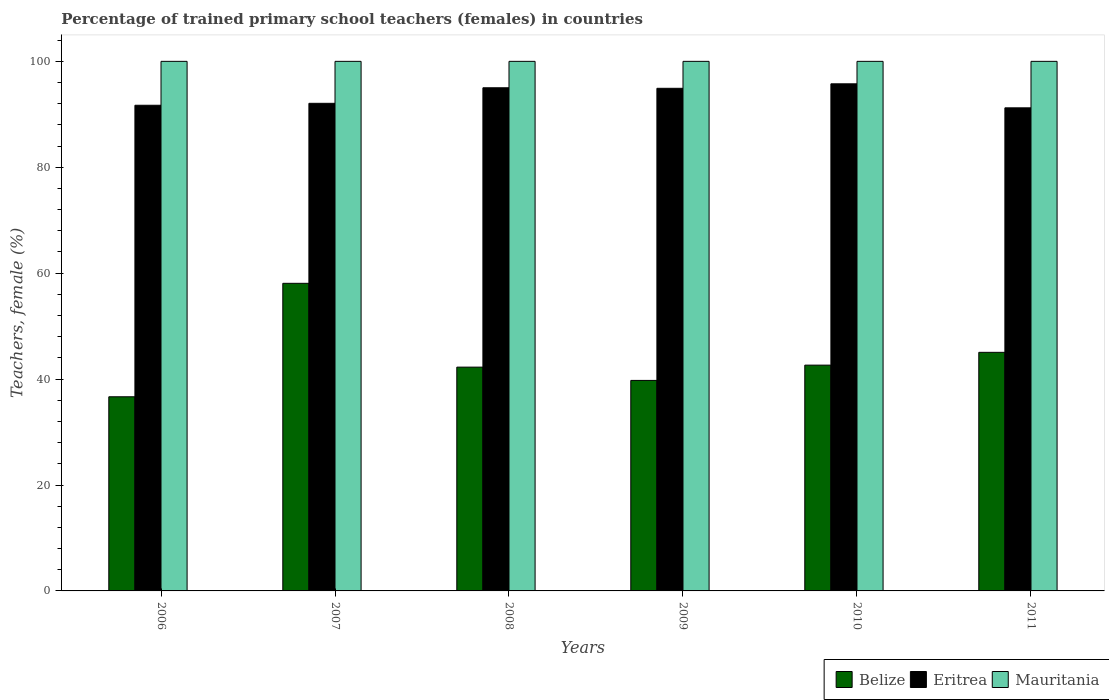How many different coloured bars are there?
Give a very brief answer. 3. Are the number of bars per tick equal to the number of legend labels?
Give a very brief answer. Yes. What is the label of the 1st group of bars from the left?
Your answer should be compact. 2006. What is the percentage of trained primary school teachers (females) in Mauritania in 2011?
Offer a terse response. 100. Across all years, what is the maximum percentage of trained primary school teachers (females) in Eritrea?
Ensure brevity in your answer.  95.76. In which year was the percentage of trained primary school teachers (females) in Eritrea minimum?
Your answer should be very brief. 2011. What is the total percentage of trained primary school teachers (females) in Eritrea in the graph?
Your response must be concise. 560.69. What is the difference between the percentage of trained primary school teachers (females) in Belize in 2007 and that in 2010?
Make the answer very short. 15.45. What is the difference between the percentage of trained primary school teachers (females) in Eritrea in 2010 and the percentage of trained primary school teachers (females) in Mauritania in 2006?
Make the answer very short. -4.24. What is the average percentage of trained primary school teachers (females) in Belize per year?
Provide a succinct answer. 44.07. In the year 2011, what is the difference between the percentage of trained primary school teachers (females) in Eritrea and percentage of trained primary school teachers (females) in Belize?
Offer a very short reply. 46.17. Is the difference between the percentage of trained primary school teachers (females) in Eritrea in 2007 and 2010 greater than the difference between the percentage of trained primary school teachers (females) in Belize in 2007 and 2010?
Your answer should be very brief. No. What is the difference between the highest and the second highest percentage of trained primary school teachers (females) in Eritrea?
Offer a terse response. 0.75. What is the difference between the highest and the lowest percentage of trained primary school teachers (females) in Belize?
Your response must be concise. 21.42. In how many years, is the percentage of trained primary school teachers (females) in Mauritania greater than the average percentage of trained primary school teachers (females) in Mauritania taken over all years?
Offer a terse response. 0. What does the 2nd bar from the left in 2008 represents?
Make the answer very short. Eritrea. What does the 3rd bar from the right in 2006 represents?
Offer a terse response. Belize. Is it the case that in every year, the sum of the percentage of trained primary school teachers (females) in Mauritania and percentage of trained primary school teachers (females) in Belize is greater than the percentage of trained primary school teachers (females) in Eritrea?
Your response must be concise. Yes. How many years are there in the graph?
Offer a terse response. 6. Does the graph contain any zero values?
Your answer should be compact. No. How are the legend labels stacked?
Offer a terse response. Horizontal. What is the title of the graph?
Ensure brevity in your answer.  Percentage of trained primary school teachers (females) in countries. Does "Qatar" appear as one of the legend labels in the graph?
Make the answer very short. No. What is the label or title of the X-axis?
Keep it short and to the point. Years. What is the label or title of the Y-axis?
Offer a terse response. Teachers, female (%). What is the Teachers, female (%) of Belize in 2006?
Give a very brief answer. 36.66. What is the Teachers, female (%) in Eritrea in 2006?
Provide a short and direct response. 91.71. What is the Teachers, female (%) of Belize in 2007?
Give a very brief answer. 58.08. What is the Teachers, female (%) of Eritrea in 2007?
Your response must be concise. 92.08. What is the Teachers, female (%) of Mauritania in 2007?
Ensure brevity in your answer.  100. What is the Teachers, female (%) in Belize in 2008?
Your answer should be very brief. 42.26. What is the Teachers, female (%) in Eritrea in 2008?
Ensure brevity in your answer.  95.01. What is the Teachers, female (%) in Belize in 2009?
Offer a terse response. 39.75. What is the Teachers, female (%) of Eritrea in 2009?
Provide a short and direct response. 94.91. What is the Teachers, female (%) in Belize in 2010?
Provide a succinct answer. 42.64. What is the Teachers, female (%) in Eritrea in 2010?
Provide a short and direct response. 95.76. What is the Teachers, female (%) of Belize in 2011?
Ensure brevity in your answer.  45.05. What is the Teachers, female (%) in Eritrea in 2011?
Provide a short and direct response. 91.22. Across all years, what is the maximum Teachers, female (%) of Belize?
Offer a very short reply. 58.08. Across all years, what is the maximum Teachers, female (%) in Eritrea?
Make the answer very short. 95.76. Across all years, what is the maximum Teachers, female (%) in Mauritania?
Offer a very short reply. 100. Across all years, what is the minimum Teachers, female (%) in Belize?
Your answer should be very brief. 36.66. Across all years, what is the minimum Teachers, female (%) of Eritrea?
Your response must be concise. 91.22. What is the total Teachers, female (%) in Belize in the graph?
Your response must be concise. 264.45. What is the total Teachers, female (%) of Eritrea in the graph?
Offer a very short reply. 560.69. What is the total Teachers, female (%) of Mauritania in the graph?
Offer a terse response. 600. What is the difference between the Teachers, female (%) in Belize in 2006 and that in 2007?
Provide a succinct answer. -21.42. What is the difference between the Teachers, female (%) of Eritrea in 2006 and that in 2007?
Offer a terse response. -0.37. What is the difference between the Teachers, female (%) in Mauritania in 2006 and that in 2007?
Your answer should be compact. 0. What is the difference between the Teachers, female (%) of Belize in 2006 and that in 2008?
Provide a succinct answer. -5.6. What is the difference between the Teachers, female (%) in Eritrea in 2006 and that in 2008?
Your response must be concise. -3.3. What is the difference between the Teachers, female (%) in Mauritania in 2006 and that in 2008?
Offer a very short reply. 0. What is the difference between the Teachers, female (%) in Belize in 2006 and that in 2009?
Keep it short and to the point. -3.09. What is the difference between the Teachers, female (%) in Eritrea in 2006 and that in 2009?
Provide a short and direct response. -3.2. What is the difference between the Teachers, female (%) in Mauritania in 2006 and that in 2009?
Give a very brief answer. 0. What is the difference between the Teachers, female (%) of Belize in 2006 and that in 2010?
Your answer should be very brief. -5.97. What is the difference between the Teachers, female (%) of Eritrea in 2006 and that in 2010?
Ensure brevity in your answer.  -4.05. What is the difference between the Teachers, female (%) of Belize in 2006 and that in 2011?
Give a very brief answer. -8.39. What is the difference between the Teachers, female (%) of Eritrea in 2006 and that in 2011?
Offer a very short reply. 0.49. What is the difference between the Teachers, female (%) in Mauritania in 2006 and that in 2011?
Your answer should be compact. 0. What is the difference between the Teachers, female (%) of Belize in 2007 and that in 2008?
Make the answer very short. 15.82. What is the difference between the Teachers, female (%) of Eritrea in 2007 and that in 2008?
Your answer should be compact. -2.94. What is the difference between the Teachers, female (%) in Belize in 2007 and that in 2009?
Provide a short and direct response. 18.33. What is the difference between the Teachers, female (%) of Eritrea in 2007 and that in 2009?
Your answer should be very brief. -2.84. What is the difference between the Teachers, female (%) in Mauritania in 2007 and that in 2009?
Ensure brevity in your answer.  0. What is the difference between the Teachers, female (%) in Belize in 2007 and that in 2010?
Give a very brief answer. 15.45. What is the difference between the Teachers, female (%) of Eritrea in 2007 and that in 2010?
Give a very brief answer. -3.68. What is the difference between the Teachers, female (%) in Belize in 2007 and that in 2011?
Keep it short and to the point. 13.03. What is the difference between the Teachers, female (%) in Eritrea in 2007 and that in 2011?
Your answer should be compact. 0.85. What is the difference between the Teachers, female (%) in Mauritania in 2007 and that in 2011?
Give a very brief answer. 0. What is the difference between the Teachers, female (%) in Belize in 2008 and that in 2009?
Ensure brevity in your answer.  2.51. What is the difference between the Teachers, female (%) in Eritrea in 2008 and that in 2009?
Give a very brief answer. 0.1. What is the difference between the Teachers, female (%) in Belize in 2008 and that in 2010?
Keep it short and to the point. -0.38. What is the difference between the Teachers, female (%) in Eritrea in 2008 and that in 2010?
Ensure brevity in your answer.  -0.75. What is the difference between the Teachers, female (%) in Belize in 2008 and that in 2011?
Give a very brief answer. -2.79. What is the difference between the Teachers, female (%) in Eritrea in 2008 and that in 2011?
Your answer should be very brief. 3.79. What is the difference between the Teachers, female (%) in Belize in 2009 and that in 2010?
Offer a very short reply. -2.88. What is the difference between the Teachers, female (%) of Eritrea in 2009 and that in 2010?
Give a very brief answer. -0.85. What is the difference between the Teachers, female (%) of Mauritania in 2009 and that in 2010?
Provide a short and direct response. 0. What is the difference between the Teachers, female (%) of Belize in 2009 and that in 2011?
Offer a terse response. -5.3. What is the difference between the Teachers, female (%) of Eritrea in 2009 and that in 2011?
Ensure brevity in your answer.  3.69. What is the difference between the Teachers, female (%) in Mauritania in 2009 and that in 2011?
Offer a very short reply. 0. What is the difference between the Teachers, female (%) in Belize in 2010 and that in 2011?
Your answer should be very brief. -2.42. What is the difference between the Teachers, female (%) of Eritrea in 2010 and that in 2011?
Provide a short and direct response. 4.54. What is the difference between the Teachers, female (%) in Mauritania in 2010 and that in 2011?
Provide a succinct answer. 0. What is the difference between the Teachers, female (%) in Belize in 2006 and the Teachers, female (%) in Eritrea in 2007?
Your answer should be very brief. -55.41. What is the difference between the Teachers, female (%) in Belize in 2006 and the Teachers, female (%) in Mauritania in 2007?
Your answer should be very brief. -63.34. What is the difference between the Teachers, female (%) of Eritrea in 2006 and the Teachers, female (%) of Mauritania in 2007?
Offer a very short reply. -8.29. What is the difference between the Teachers, female (%) in Belize in 2006 and the Teachers, female (%) in Eritrea in 2008?
Provide a succinct answer. -58.35. What is the difference between the Teachers, female (%) of Belize in 2006 and the Teachers, female (%) of Mauritania in 2008?
Give a very brief answer. -63.34. What is the difference between the Teachers, female (%) of Eritrea in 2006 and the Teachers, female (%) of Mauritania in 2008?
Offer a terse response. -8.29. What is the difference between the Teachers, female (%) of Belize in 2006 and the Teachers, female (%) of Eritrea in 2009?
Your response must be concise. -58.25. What is the difference between the Teachers, female (%) of Belize in 2006 and the Teachers, female (%) of Mauritania in 2009?
Offer a terse response. -63.34. What is the difference between the Teachers, female (%) of Eritrea in 2006 and the Teachers, female (%) of Mauritania in 2009?
Keep it short and to the point. -8.29. What is the difference between the Teachers, female (%) in Belize in 2006 and the Teachers, female (%) in Eritrea in 2010?
Your response must be concise. -59.1. What is the difference between the Teachers, female (%) in Belize in 2006 and the Teachers, female (%) in Mauritania in 2010?
Ensure brevity in your answer.  -63.34. What is the difference between the Teachers, female (%) in Eritrea in 2006 and the Teachers, female (%) in Mauritania in 2010?
Ensure brevity in your answer.  -8.29. What is the difference between the Teachers, female (%) in Belize in 2006 and the Teachers, female (%) in Eritrea in 2011?
Offer a terse response. -54.56. What is the difference between the Teachers, female (%) in Belize in 2006 and the Teachers, female (%) in Mauritania in 2011?
Keep it short and to the point. -63.34. What is the difference between the Teachers, female (%) of Eritrea in 2006 and the Teachers, female (%) of Mauritania in 2011?
Your answer should be very brief. -8.29. What is the difference between the Teachers, female (%) of Belize in 2007 and the Teachers, female (%) of Eritrea in 2008?
Offer a terse response. -36.93. What is the difference between the Teachers, female (%) of Belize in 2007 and the Teachers, female (%) of Mauritania in 2008?
Offer a terse response. -41.92. What is the difference between the Teachers, female (%) of Eritrea in 2007 and the Teachers, female (%) of Mauritania in 2008?
Ensure brevity in your answer.  -7.92. What is the difference between the Teachers, female (%) of Belize in 2007 and the Teachers, female (%) of Eritrea in 2009?
Your response must be concise. -36.83. What is the difference between the Teachers, female (%) of Belize in 2007 and the Teachers, female (%) of Mauritania in 2009?
Your response must be concise. -41.92. What is the difference between the Teachers, female (%) of Eritrea in 2007 and the Teachers, female (%) of Mauritania in 2009?
Offer a terse response. -7.92. What is the difference between the Teachers, female (%) in Belize in 2007 and the Teachers, female (%) in Eritrea in 2010?
Provide a succinct answer. -37.67. What is the difference between the Teachers, female (%) of Belize in 2007 and the Teachers, female (%) of Mauritania in 2010?
Offer a very short reply. -41.92. What is the difference between the Teachers, female (%) in Eritrea in 2007 and the Teachers, female (%) in Mauritania in 2010?
Make the answer very short. -7.92. What is the difference between the Teachers, female (%) in Belize in 2007 and the Teachers, female (%) in Eritrea in 2011?
Provide a succinct answer. -33.14. What is the difference between the Teachers, female (%) of Belize in 2007 and the Teachers, female (%) of Mauritania in 2011?
Your answer should be very brief. -41.92. What is the difference between the Teachers, female (%) in Eritrea in 2007 and the Teachers, female (%) in Mauritania in 2011?
Make the answer very short. -7.92. What is the difference between the Teachers, female (%) of Belize in 2008 and the Teachers, female (%) of Eritrea in 2009?
Give a very brief answer. -52.65. What is the difference between the Teachers, female (%) of Belize in 2008 and the Teachers, female (%) of Mauritania in 2009?
Make the answer very short. -57.74. What is the difference between the Teachers, female (%) of Eritrea in 2008 and the Teachers, female (%) of Mauritania in 2009?
Your response must be concise. -4.99. What is the difference between the Teachers, female (%) of Belize in 2008 and the Teachers, female (%) of Eritrea in 2010?
Your answer should be very brief. -53.5. What is the difference between the Teachers, female (%) of Belize in 2008 and the Teachers, female (%) of Mauritania in 2010?
Make the answer very short. -57.74. What is the difference between the Teachers, female (%) of Eritrea in 2008 and the Teachers, female (%) of Mauritania in 2010?
Your response must be concise. -4.99. What is the difference between the Teachers, female (%) of Belize in 2008 and the Teachers, female (%) of Eritrea in 2011?
Your response must be concise. -48.96. What is the difference between the Teachers, female (%) of Belize in 2008 and the Teachers, female (%) of Mauritania in 2011?
Give a very brief answer. -57.74. What is the difference between the Teachers, female (%) of Eritrea in 2008 and the Teachers, female (%) of Mauritania in 2011?
Keep it short and to the point. -4.99. What is the difference between the Teachers, female (%) of Belize in 2009 and the Teachers, female (%) of Eritrea in 2010?
Keep it short and to the point. -56.01. What is the difference between the Teachers, female (%) in Belize in 2009 and the Teachers, female (%) in Mauritania in 2010?
Your answer should be compact. -60.25. What is the difference between the Teachers, female (%) of Eritrea in 2009 and the Teachers, female (%) of Mauritania in 2010?
Give a very brief answer. -5.09. What is the difference between the Teachers, female (%) of Belize in 2009 and the Teachers, female (%) of Eritrea in 2011?
Give a very brief answer. -51.47. What is the difference between the Teachers, female (%) of Belize in 2009 and the Teachers, female (%) of Mauritania in 2011?
Offer a terse response. -60.25. What is the difference between the Teachers, female (%) of Eritrea in 2009 and the Teachers, female (%) of Mauritania in 2011?
Provide a succinct answer. -5.09. What is the difference between the Teachers, female (%) in Belize in 2010 and the Teachers, female (%) in Eritrea in 2011?
Offer a very short reply. -48.59. What is the difference between the Teachers, female (%) in Belize in 2010 and the Teachers, female (%) in Mauritania in 2011?
Your answer should be very brief. -57.36. What is the difference between the Teachers, female (%) in Eritrea in 2010 and the Teachers, female (%) in Mauritania in 2011?
Offer a very short reply. -4.24. What is the average Teachers, female (%) of Belize per year?
Provide a short and direct response. 44.07. What is the average Teachers, female (%) in Eritrea per year?
Your answer should be very brief. 93.45. What is the average Teachers, female (%) in Mauritania per year?
Your answer should be very brief. 100. In the year 2006, what is the difference between the Teachers, female (%) in Belize and Teachers, female (%) in Eritrea?
Keep it short and to the point. -55.05. In the year 2006, what is the difference between the Teachers, female (%) in Belize and Teachers, female (%) in Mauritania?
Provide a succinct answer. -63.34. In the year 2006, what is the difference between the Teachers, female (%) of Eritrea and Teachers, female (%) of Mauritania?
Your response must be concise. -8.29. In the year 2007, what is the difference between the Teachers, female (%) in Belize and Teachers, female (%) in Eritrea?
Your answer should be very brief. -33.99. In the year 2007, what is the difference between the Teachers, female (%) of Belize and Teachers, female (%) of Mauritania?
Make the answer very short. -41.92. In the year 2007, what is the difference between the Teachers, female (%) of Eritrea and Teachers, female (%) of Mauritania?
Your answer should be very brief. -7.92. In the year 2008, what is the difference between the Teachers, female (%) of Belize and Teachers, female (%) of Eritrea?
Your response must be concise. -52.75. In the year 2008, what is the difference between the Teachers, female (%) in Belize and Teachers, female (%) in Mauritania?
Your answer should be compact. -57.74. In the year 2008, what is the difference between the Teachers, female (%) in Eritrea and Teachers, female (%) in Mauritania?
Give a very brief answer. -4.99. In the year 2009, what is the difference between the Teachers, female (%) of Belize and Teachers, female (%) of Eritrea?
Provide a short and direct response. -55.16. In the year 2009, what is the difference between the Teachers, female (%) in Belize and Teachers, female (%) in Mauritania?
Provide a succinct answer. -60.25. In the year 2009, what is the difference between the Teachers, female (%) in Eritrea and Teachers, female (%) in Mauritania?
Your answer should be very brief. -5.09. In the year 2010, what is the difference between the Teachers, female (%) of Belize and Teachers, female (%) of Eritrea?
Ensure brevity in your answer.  -53.12. In the year 2010, what is the difference between the Teachers, female (%) in Belize and Teachers, female (%) in Mauritania?
Your response must be concise. -57.36. In the year 2010, what is the difference between the Teachers, female (%) in Eritrea and Teachers, female (%) in Mauritania?
Your answer should be compact. -4.24. In the year 2011, what is the difference between the Teachers, female (%) of Belize and Teachers, female (%) of Eritrea?
Your answer should be very brief. -46.17. In the year 2011, what is the difference between the Teachers, female (%) of Belize and Teachers, female (%) of Mauritania?
Give a very brief answer. -54.95. In the year 2011, what is the difference between the Teachers, female (%) in Eritrea and Teachers, female (%) in Mauritania?
Your response must be concise. -8.78. What is the ratio of the Teachers, female (%) in Belize in 2006 to that in 2007?
Your answer should be compact. 0.63. What is the ratio of the Teachers, female (%) of Eritrea in 2006 to that in 2007?
Give a very brief answer. 1. What is the ratio of the Teachers, female (%) of Belize in 2006 to that in 2008?
Your answer should be compact. 0.87. What is the ratio of the Teachers, female (%) in Eritrea in 2006 to that in 2008?
Your answer should be very brief. 0.97. What is the ratio of the Teachers, female (%) of Belize in 2006 to that in 2009?
Offer a terse response. 0.92. What is the ratio of the Teachers, female (%) in Eritrea in 2006 to that in 2009?
Your answer should be very brief. 0.97. What is the ratio of the Teachers, female (%) of Mauritania in 2006 to that in 2009?
Offer a very short reply. 1. What is the ratio of the Teachers, female (%) in Belize in 2006 to that in 2010?
Give a very brief answer. 0.86. What is the ratio of the Teachers, female (%) of Eritrea in 2006 to that in 2010?
Provide a succinct answer. 0.96. What is the ratio of the Teachers, female (%) of Mauritania in 2006 to that in 2010?
Offer a terse response. 1. What is the ratio of the Teachers, female (%) of Belize in 2006 to that in 2011?
Your response must be concise. 0.81. What is the ratio of the Teachers, female (%) in Mauritania in 2006 to that in 2011?
Keep it short and to the point. 1. What is the ratio of the Teachers, female (%) of Belize in 2007 to that in 2008?
Your response must be concise. 1.37. What is the ratio of the Teachers, female (%) in Eritrea in 2007 to that in 2008?
Offer a very short reply. 0.97. What is the ratio of the Teachers, female (%) of Mauritania in 2007 to that in 2008?
Your response must be concise. 1. What is the ratio of the Teachers, female (%) of Belize in 2007 to that in 2009?
Your answer should be compact. 1.46. What is the ratio of the Teachers, female (%) in Eritrea in 2007 to that in 2009?
Ensure brevity in your answer.  0.97. What is the ratio of the Teachers, female (%) in Mauritania in 2007 to that in 2009?
Your answer should be compact. 1. What is the ratio of the Teachers, female (%) of Belize in 2007 to that in 2010?
Your response must be concise. 1.36. What is the ratio of the Teachers, female (%) in Eritrea in 2007 to that in 2010?
Your answer should be compact. 0.96. What is the ratio of the Teachers, female (%) in Belize in 2007 to that in 2011?
Your answer should be very brief. 1.29. What is the ratio of the Teachers, female (%) of Eritrea in 2007 to that in 2011?
Ensure brevity in your answer.  1.01. What is the ratio of the Teachers, female (%) of Belize in 2008 to that in 2009?
Offer a terse response. 1.06. What is the ratio of the Teachers, female (%) in Eritrea in 2008 to that in 2009?
Provide a succinct answer. 1. What is the ratio of the Teachers, female (%) in Mauritania in 2008 to that in 2009?
Ensure brevity in your answer.  1. What is the ratio of the Teachers, female (%) of Belize in 2008 to that in 2010?
Provide a succinct answer. 0.99. What is the ratio of the Teachers, female (%) in Mauritania in 2008 to that in 2010?
Offer a terse response. 1. What is the ratio of the Teachers, female (%) in Belize in 2008 to that in 2011?
Your response must be concise. 0.94. What is the ratio of the Teachers, female (%) in Eritrea in 2008 to that in 2011?
Keep it short and to the point. 1.04. What is the ratio of the Teachers, female (%) in Mauritania in 2008 to that in 2011?
Your answer should be compact. 1. What is the ratio of the Teachers, female (%) in Belize in 2009 to that in 2010?
Your answer should be compact. 0.93. What is the ratio of the Teachers, female (%) of Eritrea in 2009 to that in 2010?
Provide a succinct answer. 0.99. What is the ratio of the Teachers, female (%) of Belize in 2009 to that in 2011?
Offer a terse response. 0.88. What is the ratio of the Teachers, female (%) of Eritrea in 2009 to that in 2011?
Keep it short and to the point. 1.04. What is the ratio of the Teachers, female (%) of Mauritania in 2009 to that in 2011?
Offer a very short reply. 1. What is the ratio of the Teachers, female (%) of Belize in 2010 to that in 2011?
Make the answer very short. 0.95. What is the ratio of the Teachers, female (%) of Eritrea in 2010 to that in 2011?
Make the answer very short. 1.05. What is the difference between the highest and the second highest Teachers, female (%) in Belize?
Provide a succinct answer. 13.03. What is the difference between the highest and the second highest Teachers, female (%) in Eritrea?
Give a very brief answer. 0.75. What is the difference between the highest and the second highest Teachers, female (%) of Mauritania?
Provide a succinct answer. 0. What is the difference between the highest and the lowest Teachers, female (%) in Belize?
Offer a terse response. 21.42. What is the difference between the highest and the lowest Teachers, female (%) in Eritrea?
Offer a terse response. 4.54. 